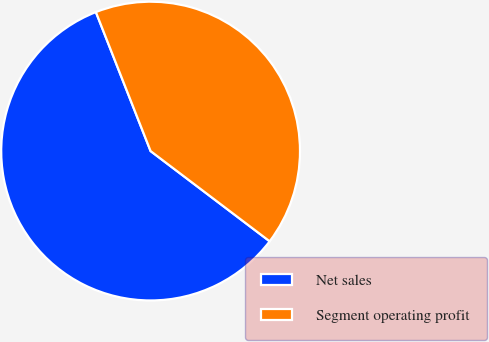<chart> <loc_0><loc_0><loc_500><loc_500><pie_chart><fcel>Net sales<fcel>Segment operating profit<nl><fcel>58.71%<fcel>41.29%<nl></chart> 